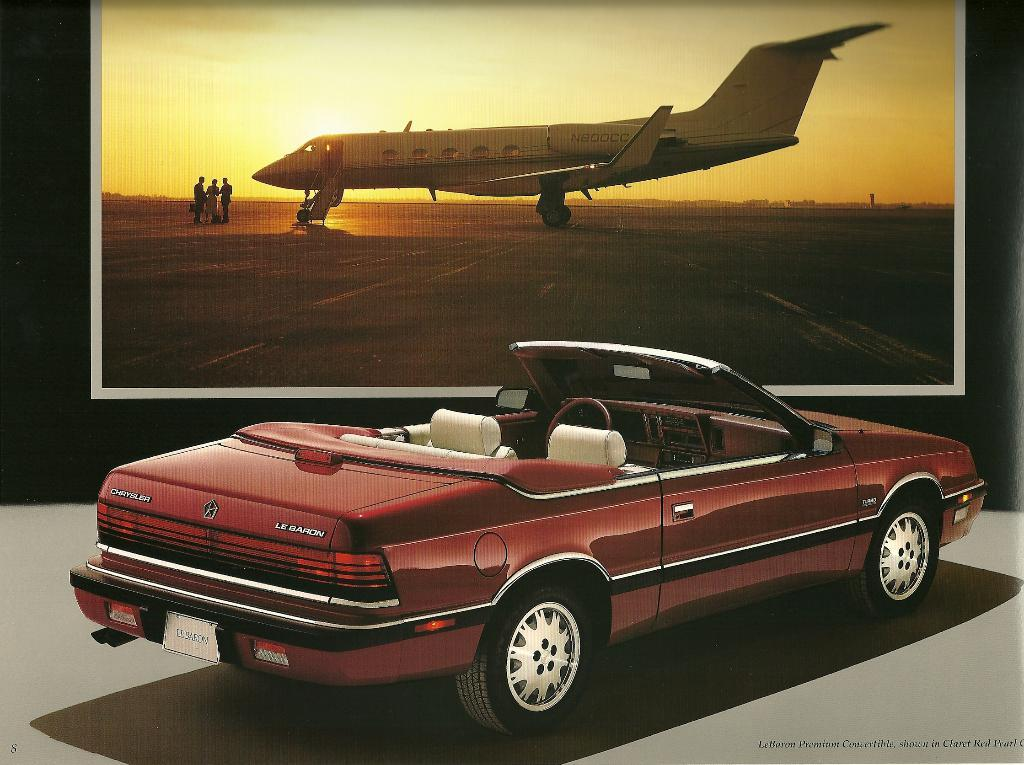<image>
Give a short and clear explanation of the subsequent image. A convertible parked by a photo of an airplane has a license plate that says LEBARON. 